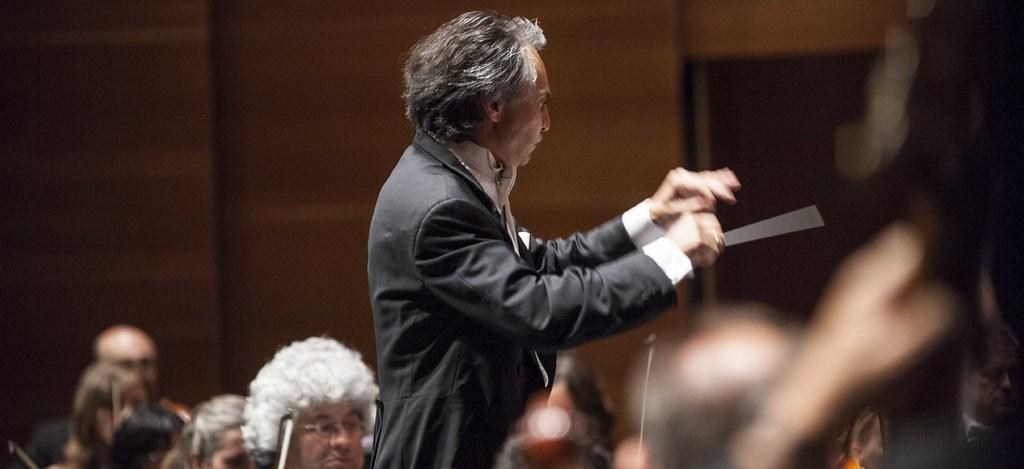What is the person holding in the image? The information provided does not specify what the person is holding. Can you describe the people at the bottom of the image? There are people at the bottom of the image, but their specific features or actions are not mentioned. What can be seen in the background of the image? There is a wall in the background of the image. How would you describe the quality of the image? The image is blurry. What is the uncle's elbow doing in the image? There is no mention of an uncle or an elbow in the image. 